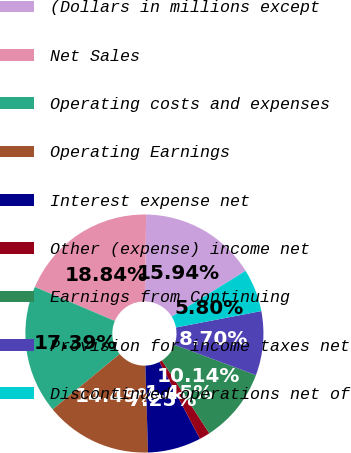<chart> <loc_0><loc_0><loc_500><loc_500><pie_chart><fcel>(Dollars in millions except<fcel>Net Sales<fcel>Operating costs and expenses<fcel>Operating Earnings<fcel>Interest expense net<fcel>Other (expense) income net<fcel>Earnings from Continuing<fcel>Provision for income taxes net<fcel>Discontinued operations net of<nl><fcel>15.94%<fcel>18.84%<fcel>17.39%<fcel>14.49%<fcel>7.25%<fcel>1.45%<fcel>10.14%<fcel>8.7%<fcel>5.8%<nl></chart> 